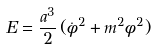<formula> <loc_0><loc_0><loc_500><loc_500>E = \frac { a ^ { 3 } } { 2 } \, ( \dot { \phi } ^ { 2 } + m ^ { 2 } \phi ^ { 2 } )</formula> 